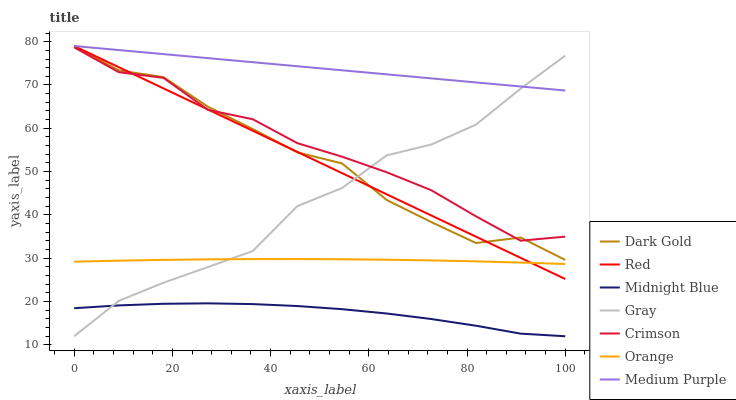Does Dark Gold have the minimum area under the curve?
Answer yes or no. No. Does Dark Gold have the maximum area under the curve?
Answer yes or no. No. Is Midnight Blue the smoothest?
Answer yes or no. No. Is Midnight Blue the roughest?
Answer yes or no. No. Does Dark Gold have the lowest value?
Answer yes or no. No. Does Midnight Blue have the highest value?
Answer yes or no. No. Is Midnight Blue less than Medium Purple?
Answer yes or no. Yes. Is Crimson greater than Midnight Blue?
Answer yes or no. Yes. Does Midnight Blue intersect Medium Purple?
Answer yes or no. No. 